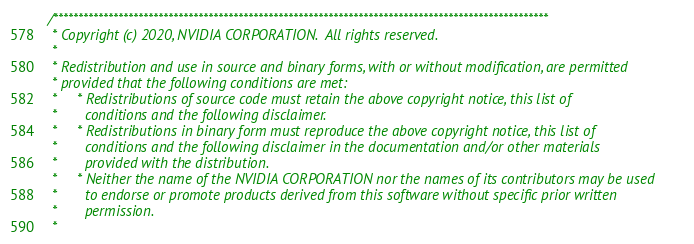<code> <loc_0><loc_0><loc_500><loc_500><_Cuda_>/***************************************************************************************************
 * Copyright (c) 2020, NVIDIA CORPORATION.  All rights reserved.
 *
 * Redistribution and use in source and binary forms, with or without modification, are permitted
 * provided that the following conditions are met:
 *     * Redistributions of source code must retain the above copyright notice, this list of
 *       conditions and the following disclaimer.
 *     * Redistributions in binary form must reproduce the above copyright notice, this list of
 *       conditions and the following disclaimer in the documentation and/or other materials
 *       provided with the distribution.
 *     * Neither the name of the NVIDIA CORPORATION nor the names of its contributors may be used
 *       to endorse or promote products derived from this software without specific prior written
 *       permission.
 *</code> 